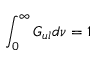<formula> <loc_0><loc_0><loc_500><loc_500>\int _ { 0 } ^ { \infty } G _ { u l } d \nu = 1</formula> 